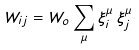<formula> <loc_0><loc_0><loc_500><loc_500>W _ { i j } = W _ { o } \sum _ { \mu } \xi _ { i } ^ { \mu } \, \xi _ { j } ^ { \mu }</formula> 